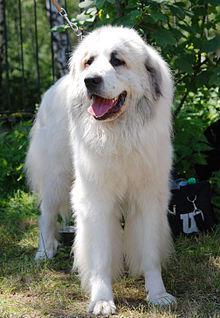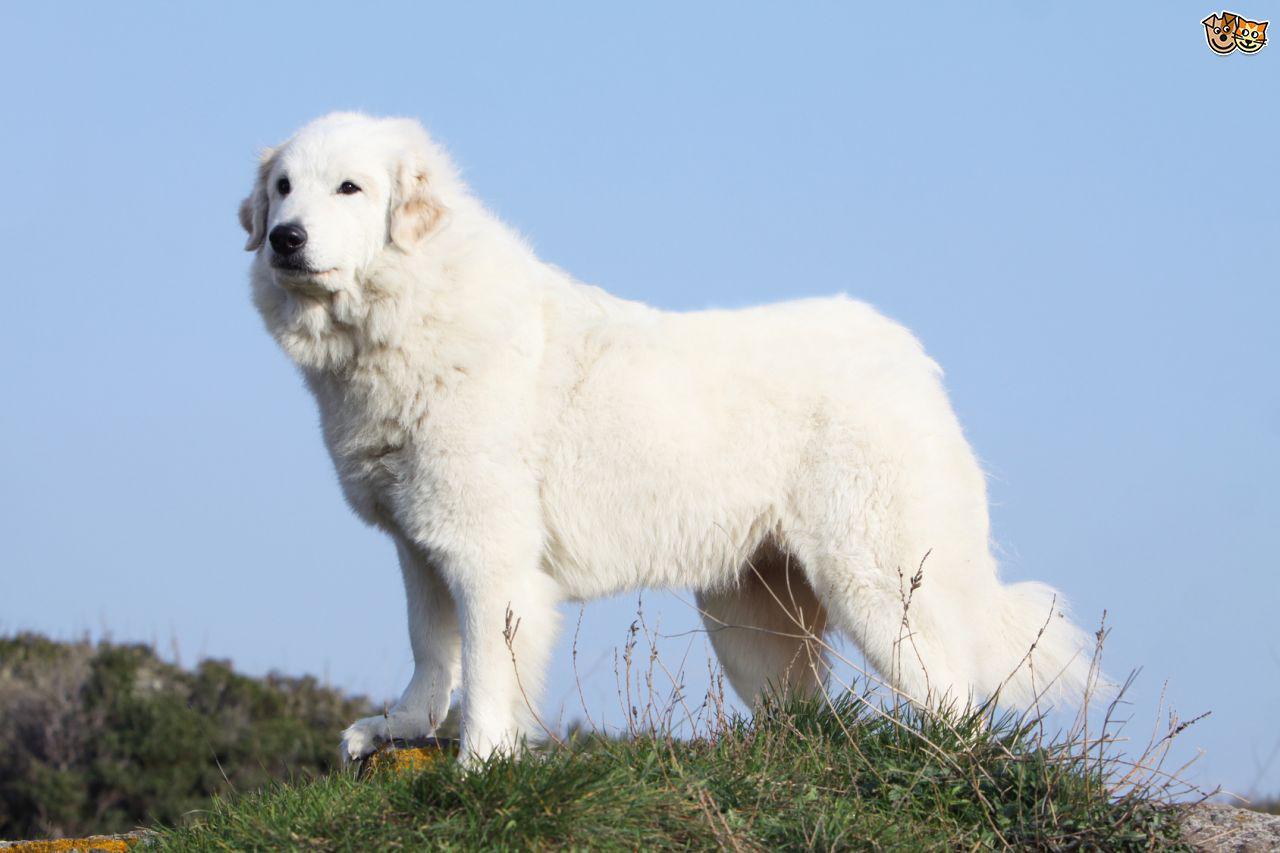The first image is the image on the left, the second image is the image on the right. For the images displayed, is the sentence "One of the dogs has its tongue visible." factually correct? Answer yes or no. Yes. 